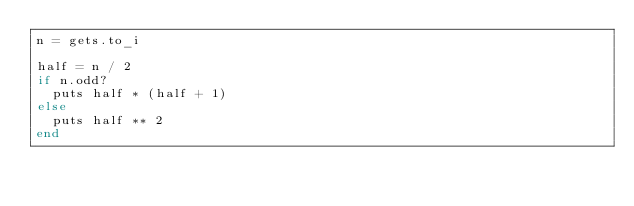<code> <loc_0><loc_0><loc_500><loc_500><_Ruby_>n = gets.to_i

half = n / 2
if n.odd?
  puts half * (half + 1)
else
  puts half ** 2
end</code> 